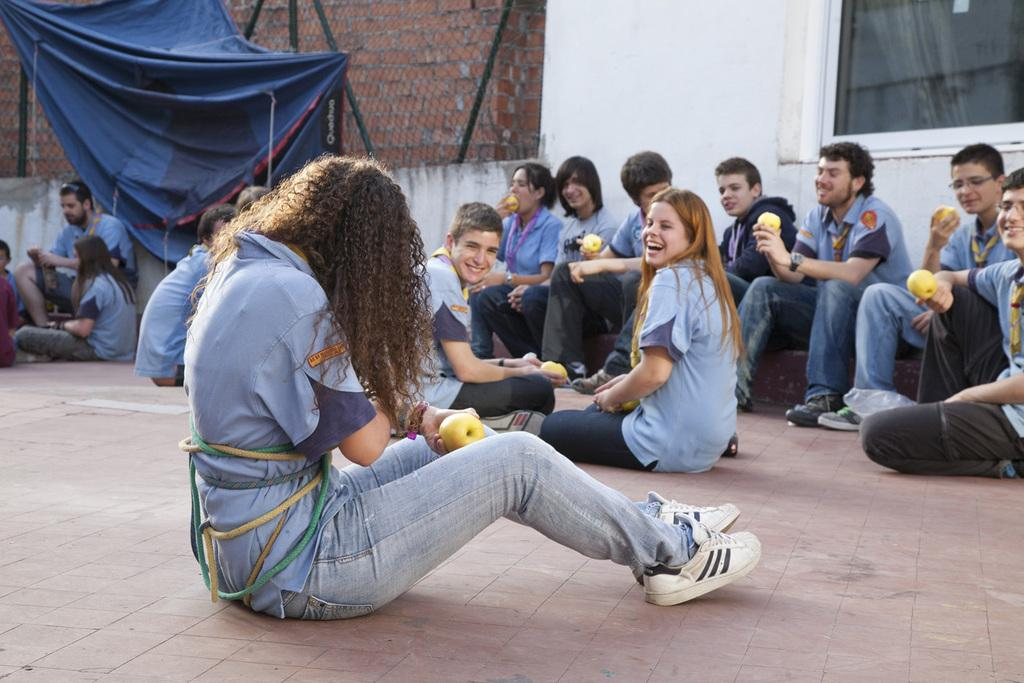What are the people in the image doing? The people in the image are seated. What objects are some of the people holding? Some people are holding apples in their hands. What type of material is visible in the image? There is a cloth visible in the image. What type of barrier is present in the image? A metal fence is present in the image. What structure can be seen on the right side of the image? There is a wall on the right side of the image. Reasoning: Let' Let's think step by step in order to produce the conversation. We start by identifying the main subjects in the image, which are the people. Then, we describe what they are doing and what objects they are holding. Next, we mention the materials and structures visible in the image, such as the cloth, metal fence, and wall. Each question is designed to elicit a specific detail about the image that is known from the provided facts. Absurd Question/Answer: What type of rice is being served on the wrist in the image? There is no rice or wrist present in the image. What type of loaf is being used as a pillow by the people in the image? There is no loaf being used as a pillow in the image. 